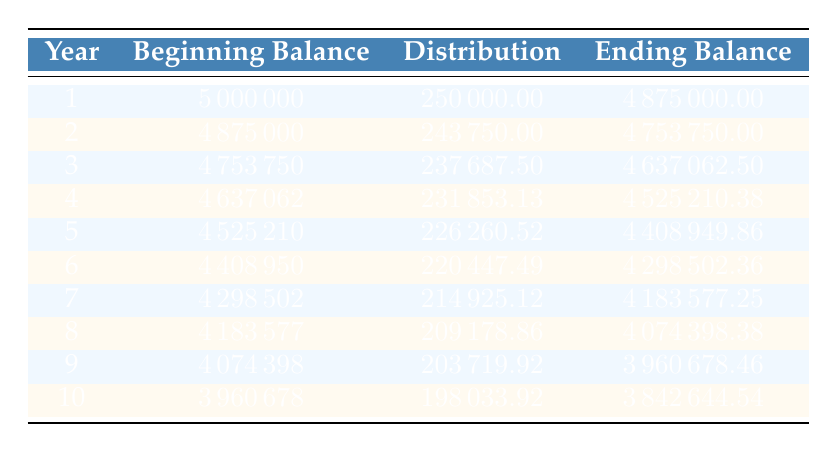What was the distribution amount in year 5? The table indicates that the distribution amount for year 5 is shown in the third column under the row corresponding to year 5, which is 226260.52.
Answer: 226260.52 What is the ending balance at the end of year 3? The ending balance for year 3 is located in the fourth column, directly corresponding to the row designated for year 3. It is 4637062.50.
Answer: 4637062.50 How much total was distributed over the 10 years? To find the total distribution amount over 10 years, we can sum the distribution amounts from each year: 250000 + 243750 + 237687.5 + 231853.13 + 226260.52 + 220447.49 + 214925.12 + 209178.86 + 203719.92 + 198033.92. The total is 2,360,000.00.
Answer: 2360000.00 Does the ending balance decrease every year? By examining the ending balances for each year in the table, we see that they steadily decrease from year 1 (4875000) to year 10 (3842644.54). Therefore, yes, the ending balance decreases each year.
Answer: Yes What is the average distribution amount from year 1 to year 10? To compute the average distribution, sum all the distribution amounts (250000 + 243750 + 237687.5 + ... + 198033.92) and divide by 10. The sum totals to 2360000.00, so the average is 2360000.00 / 10 = 236000.00.
Answer: 236000.00 What was the maximum distribution amount in a single year? Looking across the distribution amounts in the table, the maximum distribution can be found in year 1, which is 250000. The other values are less than this.
Answer: 250000 Is the ending balance after year 4 greater than the ending balance after year 6? Year 4's ending balance is 4525210.38 and year 6's is 4298502.36. Comparing these, year 4's ending balance is indeed greater than that of year 6.
Answer: Yes What is the percentage decrease in the ending balance from year 1 to year 10? The percentage decrease can be calculated by taking the difference between the ending balances of year 1 and year 10, which is 4875000 - 3842644.54 = 1032355.46. The decrease percentage is then (1032355.46 / 4875000) × 100, which equals approximately 21.14%.
Answer: 21.14% 